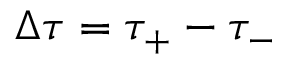Convert formula to latex. <formula><loc_0><loc_0><loc_500><loc_500>\Delta \tau = \tau _ { + } - \tau _ { - }</formula> 